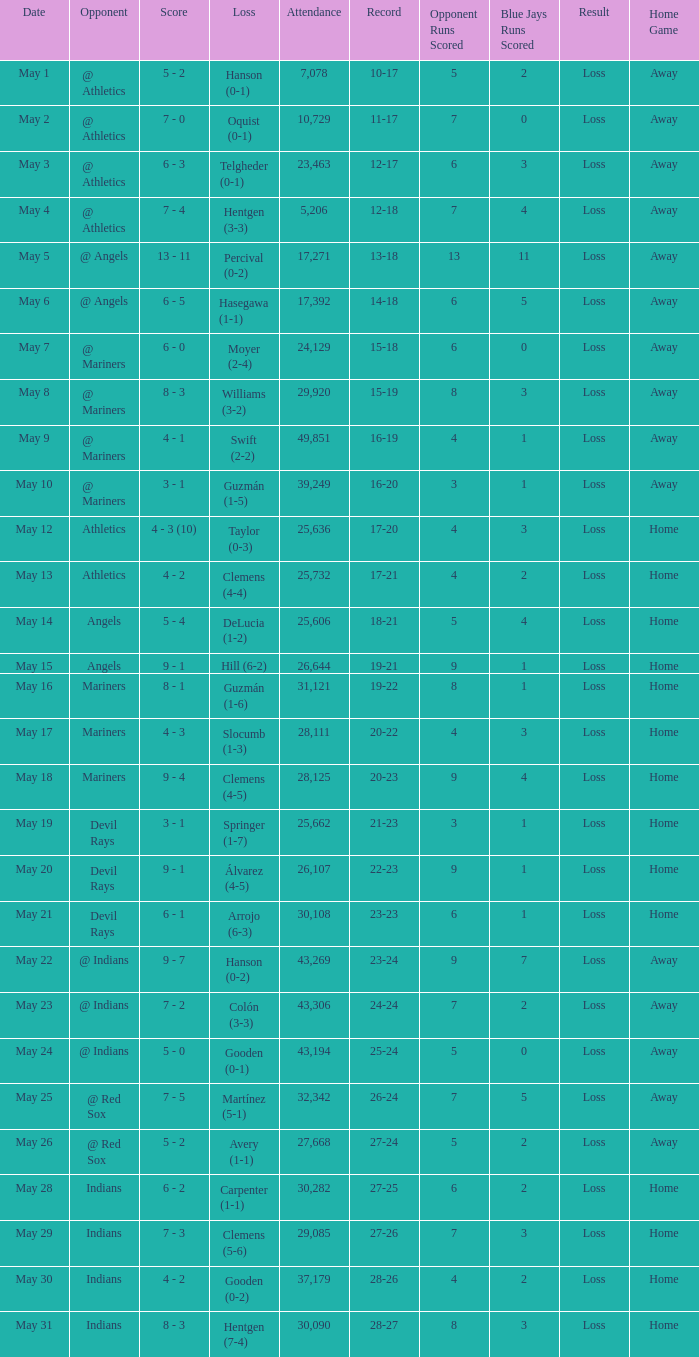Who lost on May 31? Hentgen (7-4). 